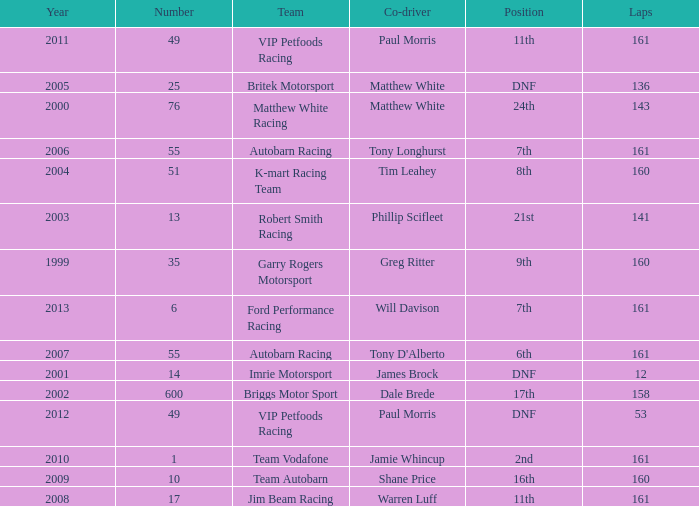What is the fewest laps for a team with a position of DNF and a number smaller than 25 before 2001? None. 